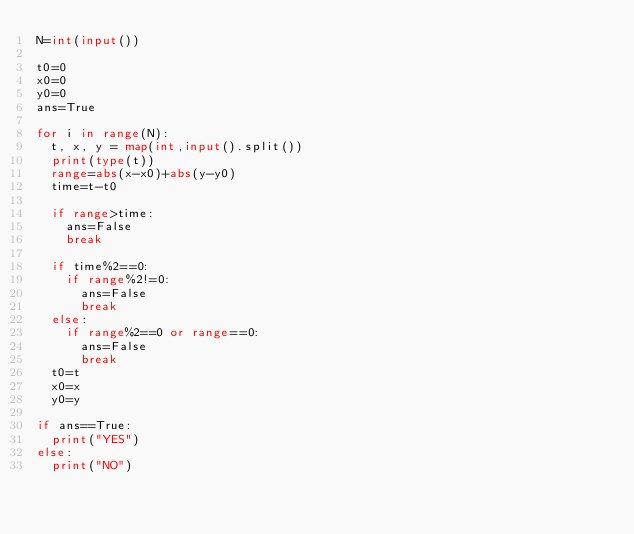<code> <loc_0><loc_0><loc_500><loc_500><_Python_>N=int(input())

t0=0
x0=0
y0=0
ans=True

for i in range(N):
  t, x, y = map(int,input().split())
  print(type(t))
  range=abs(x-x0)+abs(y-y0)
  time=t-t0
  
  if range>time:
    ans=False
    break
    
  if time%2==0:
    if range%2!=0:
      ans=False
      break
  else:
    if range%2==0 or range==0:
      ans=False
      break
  t0=t
  x0=x
  y0=y

if ans==True:
  print("YES")
else:
  print("NO")</code> 